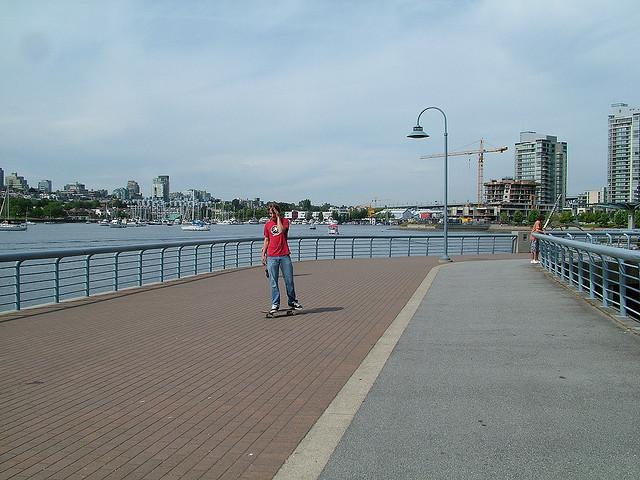Is he on the Riverside?
Concise answer only. Yes. What is he doing?
Answer briefly. Skateboarding. Is it midday?
Write a very short answer. Yes. What is the man on the left holding?
Concise answer only. Phone. Does the person on the skateboard look tired?
Keep it brief. Yes. 